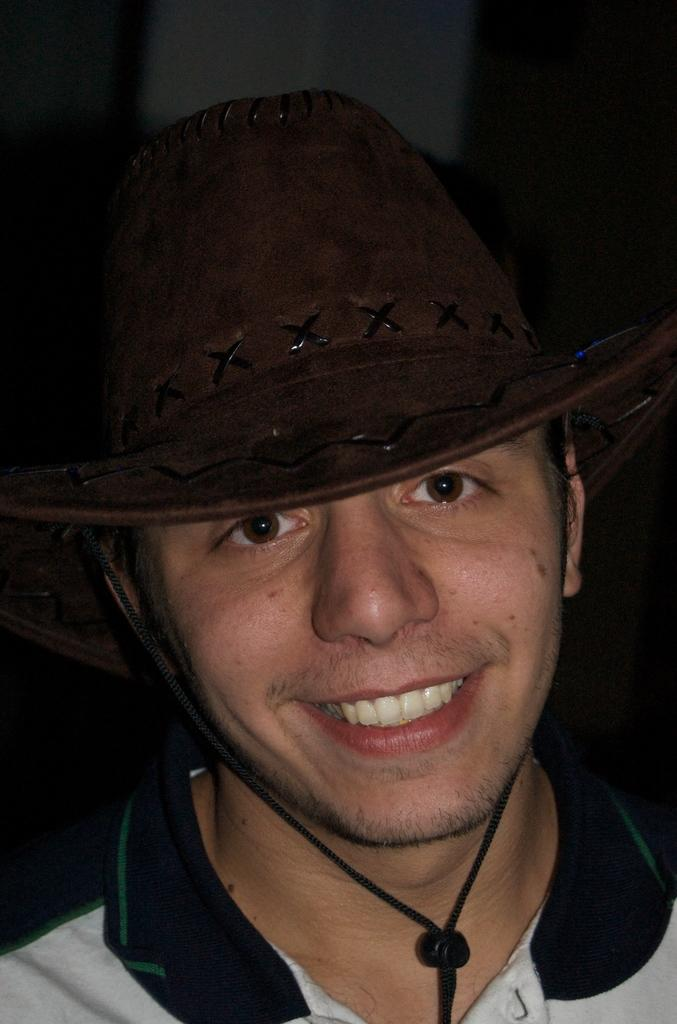Who is present in the image? There is a man in the image. What is the man wearing on his head? The man is wearing a hat. Can you describe the background of the image? The background of the image is dark and not clear to describe. What grade of orange is the man holding in the image? There is no orange present in the image, and therefore no grade can be determined. 